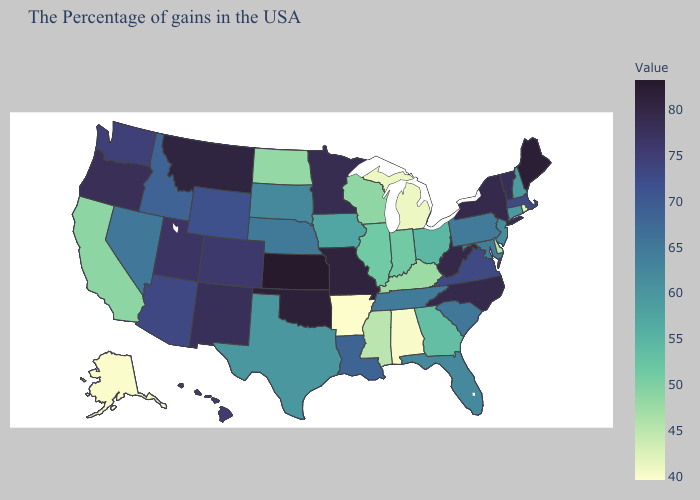Does New York have the lowest value in the Northeast?
Short answer required. No. Does Arkansas have the lowest value in the USA?
Give a very brief answer. Yes. Does Arkansas have the lowest value in the USA?
Keep it brief. Yes. Among the states that border North Carolina , does South Carolina have the highest value?
Write a very short answer. No. Does South Dakota have the highest value in the USA?
Give a very brief answer. No. Among the states that border Iowa , which have the highest value?
Write a very short answer. Missouri. Does Michigan have the lowest value in the MidWest?
Answer briefly. Yes. 